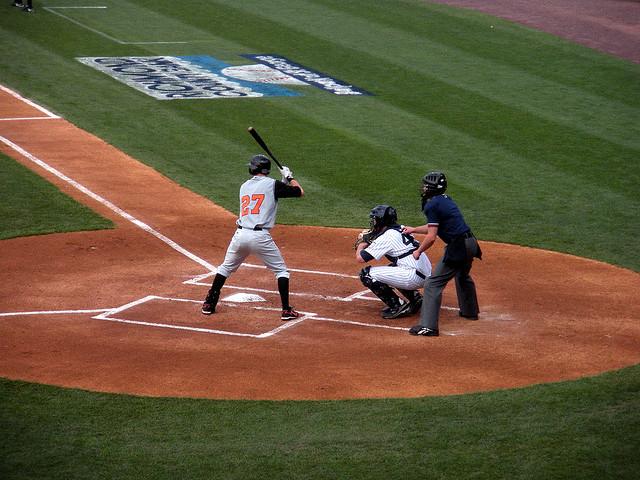What is the catcher number on the Jersey?
Quick response, please. 4. How many people are in this picture?
Give a very brief answer. 3. Is this a picture of a baseball field with a batter up at bat?
Keep it brief. Yes. 